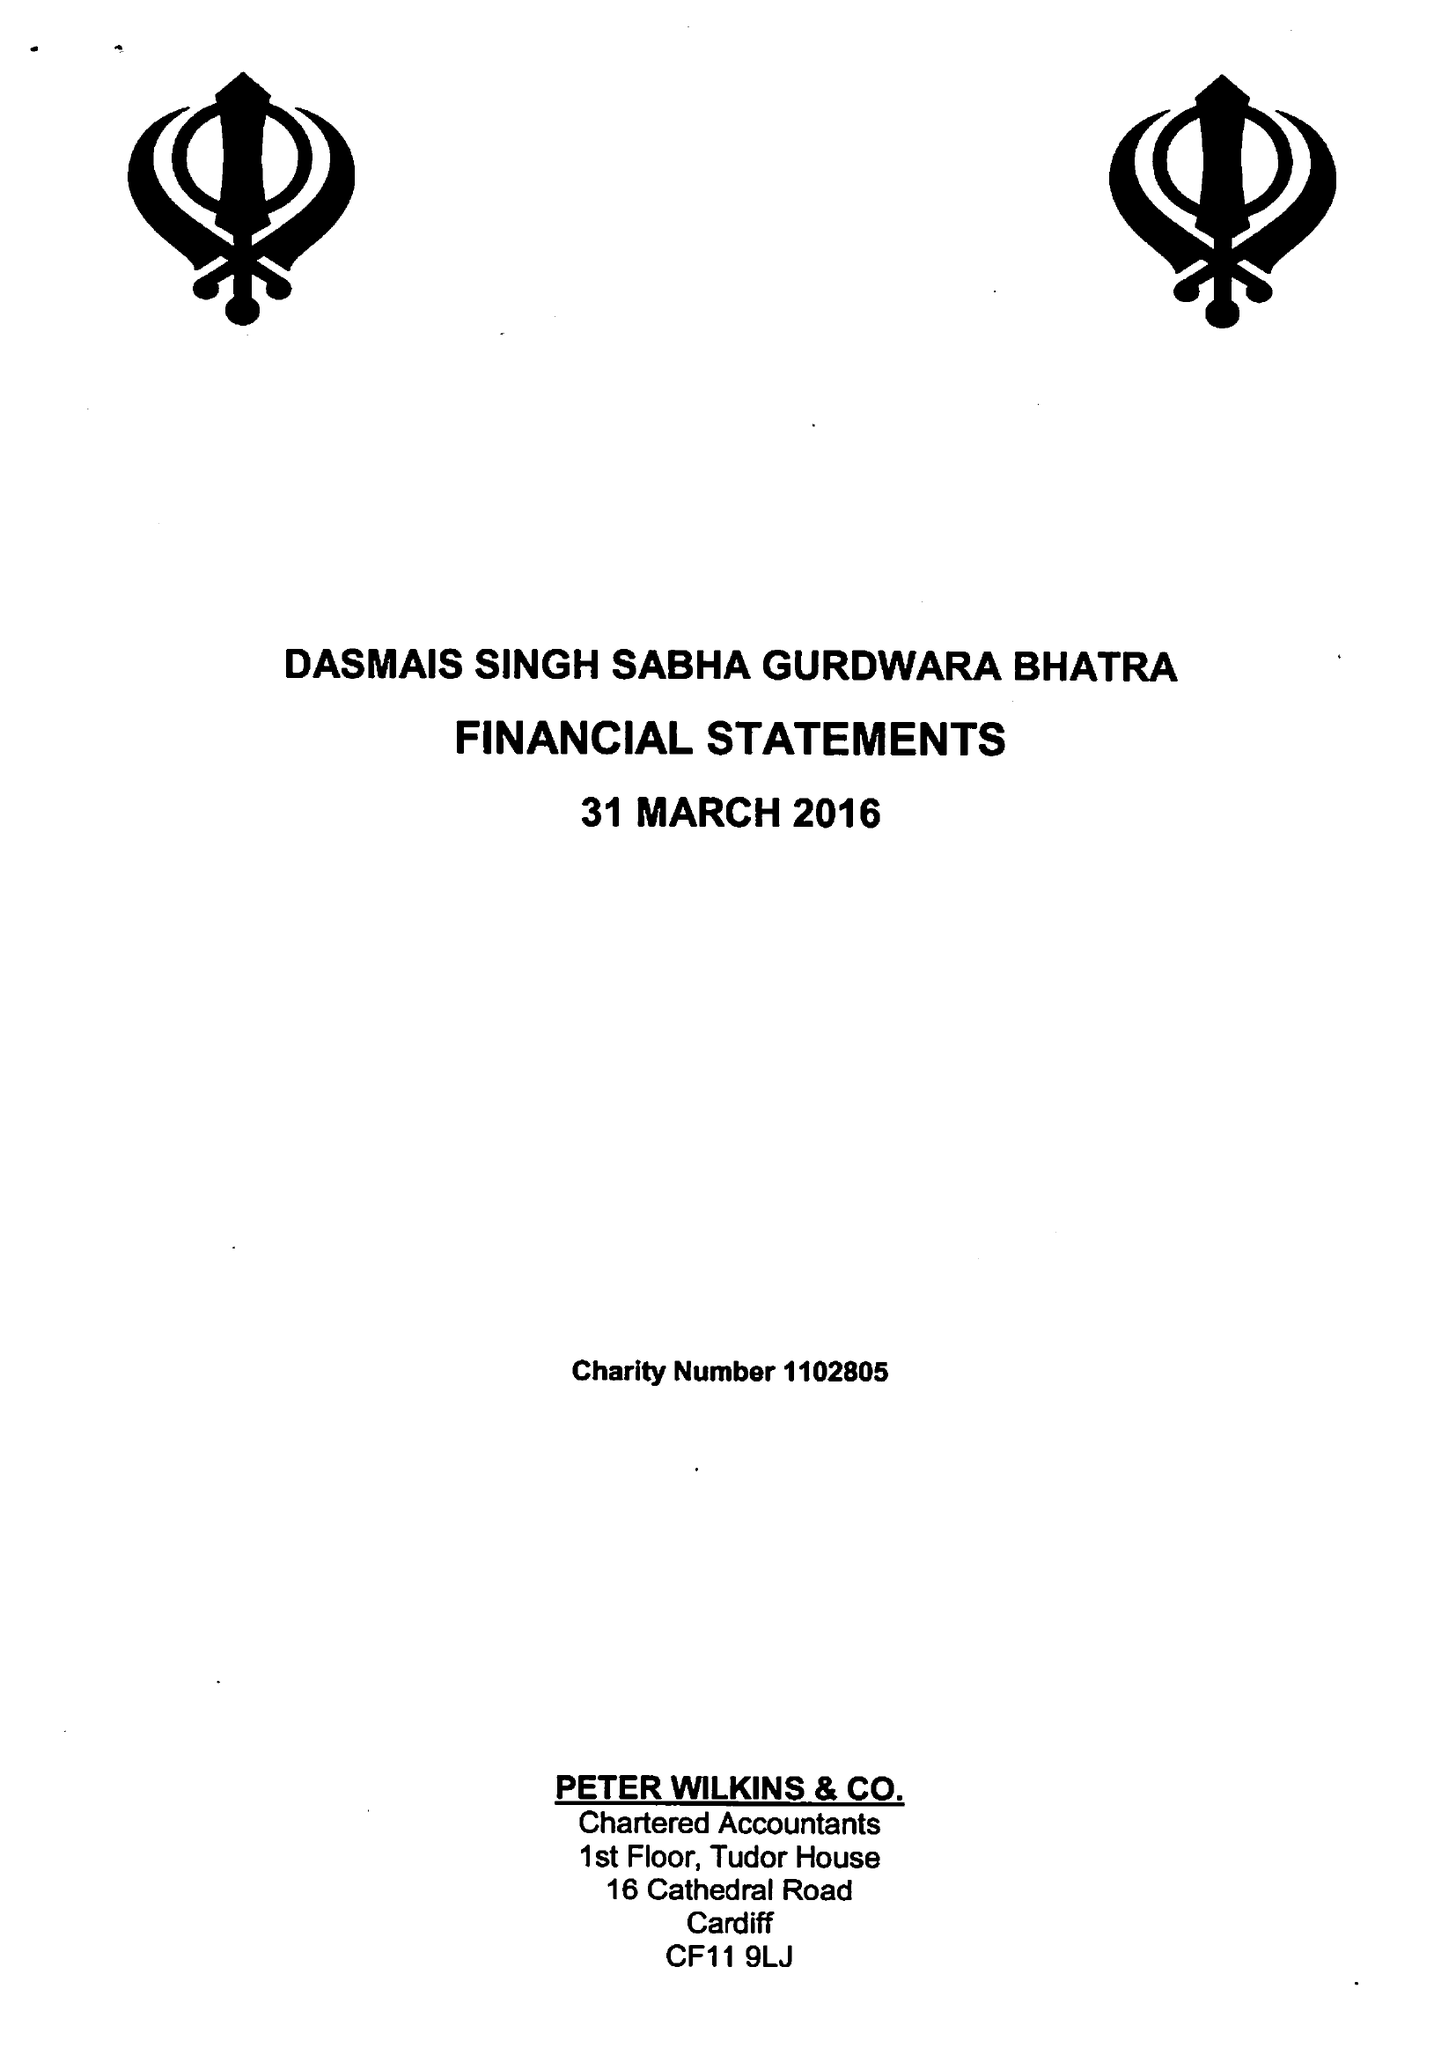What is the value for the report_date?
Answer the question using a single word or phrase. 2016-03-31 